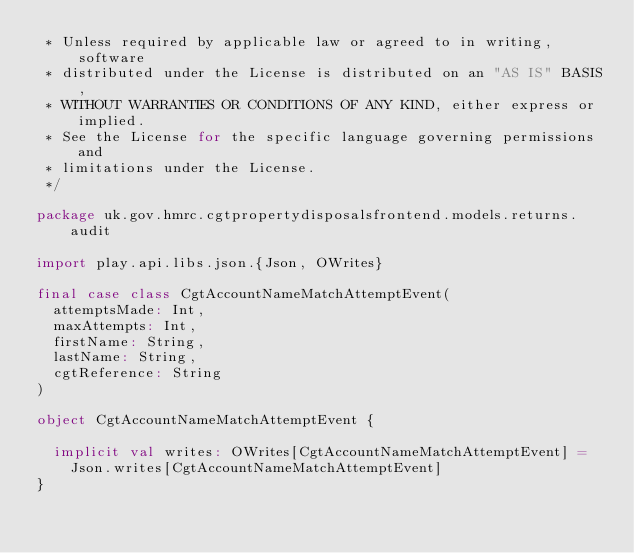<code> <loc_0><loc_0><loc_500><loc_500><_Scala_> * Unless required by applicable law or agreed to in writing, software
 * distributed under the License is distributed on an "AS IS" BASIS,
 * WITHOUT WARRANTIES OR CONDITIONS OF ANY KIND, either express or implied.
 * See the License for the specific language governing permissions and
 * limitations under the License.
 */

package uk.gov.hmrc.cgtpropertydisposalsfrontend.models.returns.audit

import play.api.libs.json.{Json, OWrites}

final case class CgtAccountNameMatchAttemptEvent(
  attemptsMade: Int,
  maxAttempts: Int,
  firstName: String,
  lastName: String,
  cgtReference: String
)

object CgtAccountNameMatchAttemptEvent {

  implicit val writes: OWrites[CgtAccountNameMatchAttemptEvent] =
    Json.writes[CgtAccountNameMatchAttemptEvent]
}
</code> 